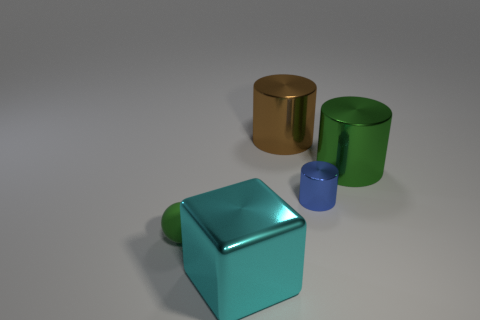There is a matte ball that is the same size as the blue cylinder; what is its color?
Give a very brief answer. Green. What number of large things are either green metal things or blue rubber spheres?
Make the answer very short. 1. What is the material of the object that is both behind the large cyan shiny cube and to the left of the large brown metal object?
Offer a very short reply. Rubber. Is the shape of the large thing that is to the right of the small metallic object the same as the blue metallic thing on the right side of the cyan thing?
Your response must be concise. Yes. What is the shape of the big shiny thing that is the same color as the tiny rubber object?
Your answer should be very brief. Cylinder. What number of objects are green things behind the green matte object or large blue metal cubes?
Ensure brevity in your answer.  1. Do the brown shiny thing and the green cylinder have the same size?
Give a very brief answer. Yes. What is the color of the small thing right of the large brown object?
Keep it short and to the point. Blue. What size is the blue object that is the same material as the brown cylinder?
Keep it short and to the point. Small. Do the blue shiny cylinder and the green object to the left of the cyan shiny object have the same size?
Give a very brief answer. Yes. 